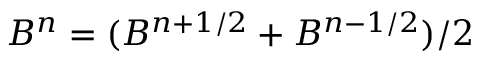Convert formula to latex. <formula><loc_0><loc_0><loc_500><loc_500>B ^ { n } = ( B ^ { n + 1 / 2 } + B ^ { n - 1 / 2 } ) / 2</formula> 